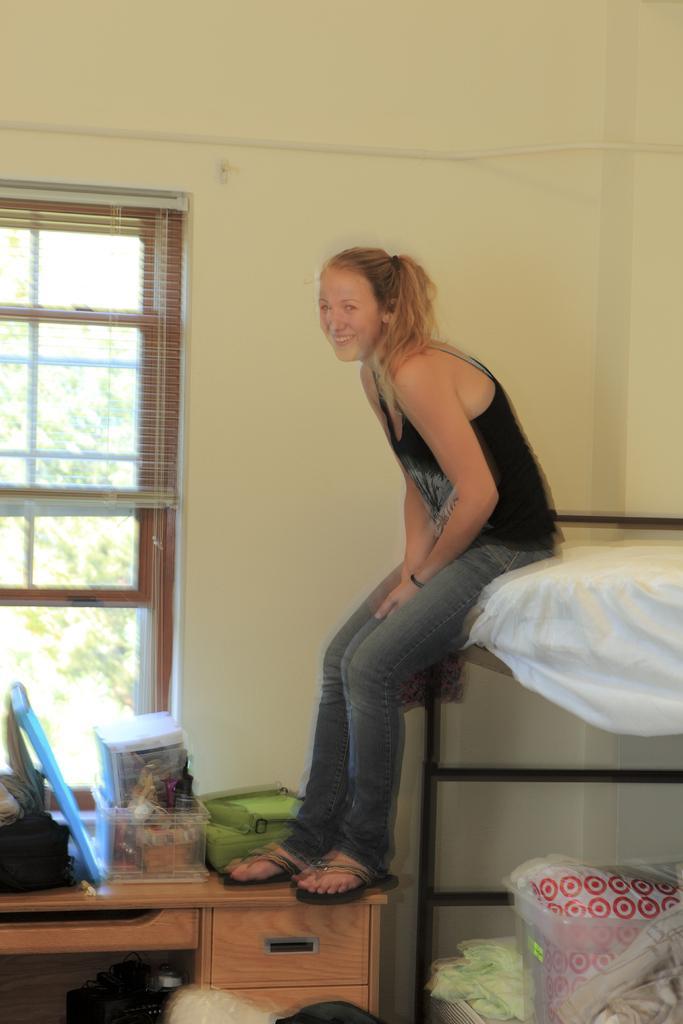Please provide a concise description of this image. This woman is sitting on a double cot bed. On this bed there is a container with clothes. On this desk there is a box and bag. Outside of this window we can able to see trees. 